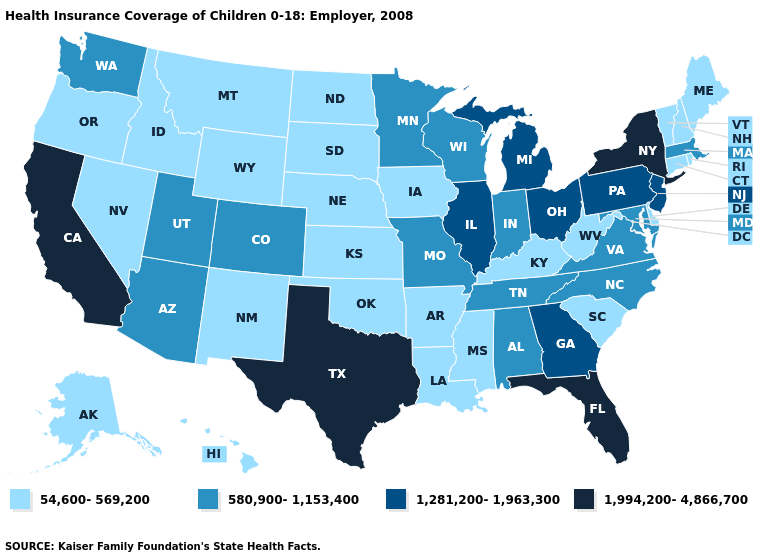Which states have the lowest value in the USA?
Answer briefly. Alaska, Arkansas, Connecticut, Delaware, Hawaii, Idaho, Iowa, Kansas, Kentucky, Louisiana, Maine, Mississippi, Montana, Nebraska, Nevada, New Hampshire, New Mexico, North Dakota, Oklahoma, Oregon, Rhode Island, South Carolina, South Dakota, Vermont, West Virginia, Wyoming. Does the first symbol in the legend represent the smallest category?
Short answer required. Yes. Does the map have missing data?
Be succinct. No. Which states have the lowest value in the USA?
Short answer required. Alaska, Arkansas, Connecticut, Delaware, Hawaii, Idaho, Iowa, Kansas, Kentucky, Louisiana, Maine, Mississippi, Montana, Nebraska, Nevada, New Hampshire, New Mexico, North Dakota, Oklahoma, Oregon, Rhode Island, South Carolina, South Dakota, Vermont, West Virginia, Wyoming. Name the states that have a value in the range 54,600-569,200?
Give a very brief answer. Alaska, Arkansas, Connecticut, Delaware, Hawaii, Idaho, Iowa, Kansas, Kentucky, Louisiana, Maine, Mississippi, Montana, Nebraska, Nevada, New Hampshire, New Mexico, North Dakota, Oklahoma, Oregon, Rhode Island, South Carolina, South Dakota, Vermont, West Virginia, Wyoming. Name the states that have a value in the range 1,281,200-1,963,300?
Write a very short answer. Georgia, Illinois, Michigan, New Jersey, Ohio, Pennsylvania. What is the lowest value in the USA?
Keep it brief. 54,600-569,200. What is the value of New York?
Give a very brief answer. 1,994,200-4,866,700. Does the first symbol in the legend represent the smallest category?
Write a very short answer. Yes. Name the states that have a value in the range 54,600-569,200?
Keep it brief. Alaska, Arkansas, Connecticut, Delaware, Hawaii, Idaho, Iowa, Kansas, Kentucky, Louisiana, Maine, Mississippi, Montana, Nebraska, Nevada, New Hampshire, New Mexico, North Dakota, Oklahoma, Oregon, Rhode Island, South Carolina, South Dakota, Vermont, West Virginia, Wyoming. What is the highest value in the Northeast ?
Short answer required. 1,994,200-4,866,700. Does the first symbol in the legend represent the smallest category?
Concise answer only. Yes. Does the map have missing data?
Be succinct. No. Which states hav the highest value in the Northeast?
Write a very short answer. New York. Name the states that have a value in the range 1,281,200-1,963,300?
Write a very short answer. Georgia, Illinois, Michigan, New Jersey, Ohio, Pennsylvania. 